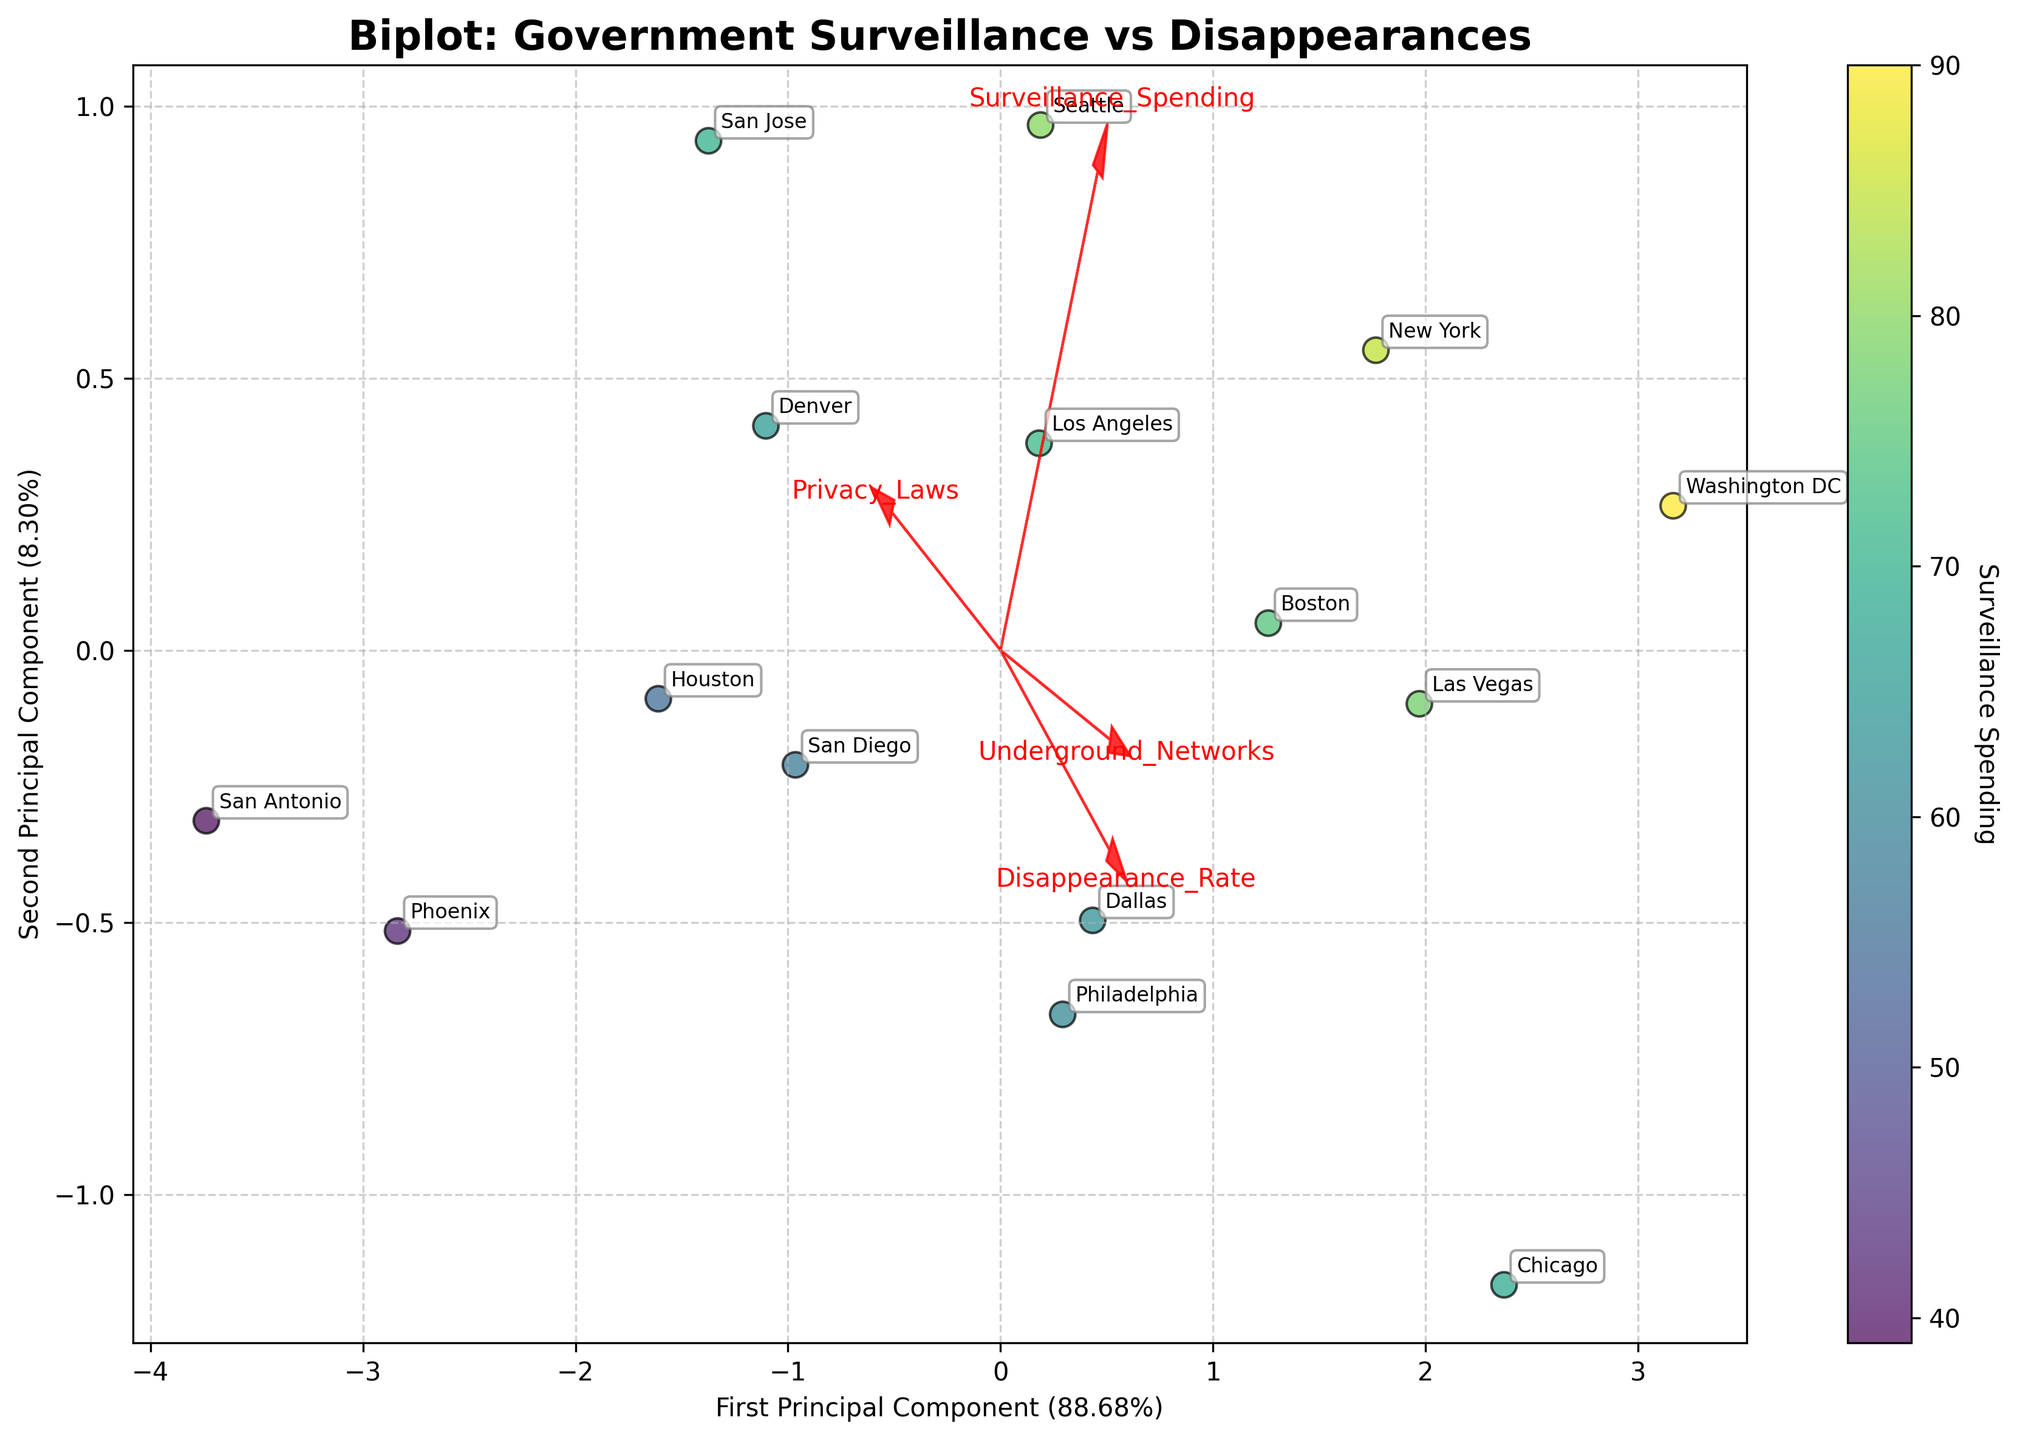What does the color of the data points represent? The color of the data points represents surveillance spending, with a color scale that likely ranges from low to high spending values.
Answer: Surveillance spending Which city has the highest surveillance spending? The city with the highest surveillance spending is represented by the data point with the darkest color. This data point is labeled "Washington DC".
Answer: Washington DC Can you find a relationship between surveillance spending and disappearance rates based on the plot? To detect a relationship, look at the data points and their positions relative to both axes. While some cities with high surveillance spending have high disappearance rates (e.g., Washington DC and Chicago), this trend is not consistent across all cities.
Answer: Somewhat Which feature appears to have a strong correlation with the second principal component? The feature vector that extends furthest along the second principal component likely has a strong correlation. In this case, the "Disappearance Rate" seems to have a strong correlation with the second principal component.
Answer: Disappearance Rate What can you infer about cities with strong privacy laws based on their positions and surveillance spending? Cities with strong privacy laws like Houston and San Jose are positioned lower on the surveillance spending scale, indicated by relatively lighter colors. This suggests that strict privacy laws might correlate with lower spending on surveillance.
Answer: Lower surveillance spending Which two cities have the closest data points in the plot? Observe the proximity of data points to assess the closest pair. New York and Boston are very close to each other in the plot.
Answer: New York and Boston What do the red arrows in the plot represent? The red arrows represent features in the dataset. Each arrow points in the direction of increasing values for that feature, and its length shows the strength of the feature's contribution to the principal components.
Answer: Dataset features How does Seattle's disappearance rate compare to Philadelphia's based on their positions? Seattle and Philadelphia can be compared on the disappearance rate scale by looking at their positions along the axis associated with Disappearance Rate. Seattle has a lower disappearance rate compared to Philadelphia.
Answer: Lower What does the first principal component explain about the dataset? Refer to the x-axis label for the first principal component's explained variance. It shows how much of the dataset's total variance is captured by this component. The x-axis label indicates it explains 35.2% of the variance.
Answer: 35.2% Which cities are closely associated with high values of underground networks? The vector "Underground Networks" points in a specific direction. The cities closest to or in this direction, like Chicago and Washington DC, indicate higher values of underground networks.
Answer: Chicago and Washington DC 